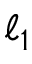<formula> <loc_0><loc_0><loc_500><loc_500>\ell _ { 1 }</formula> 